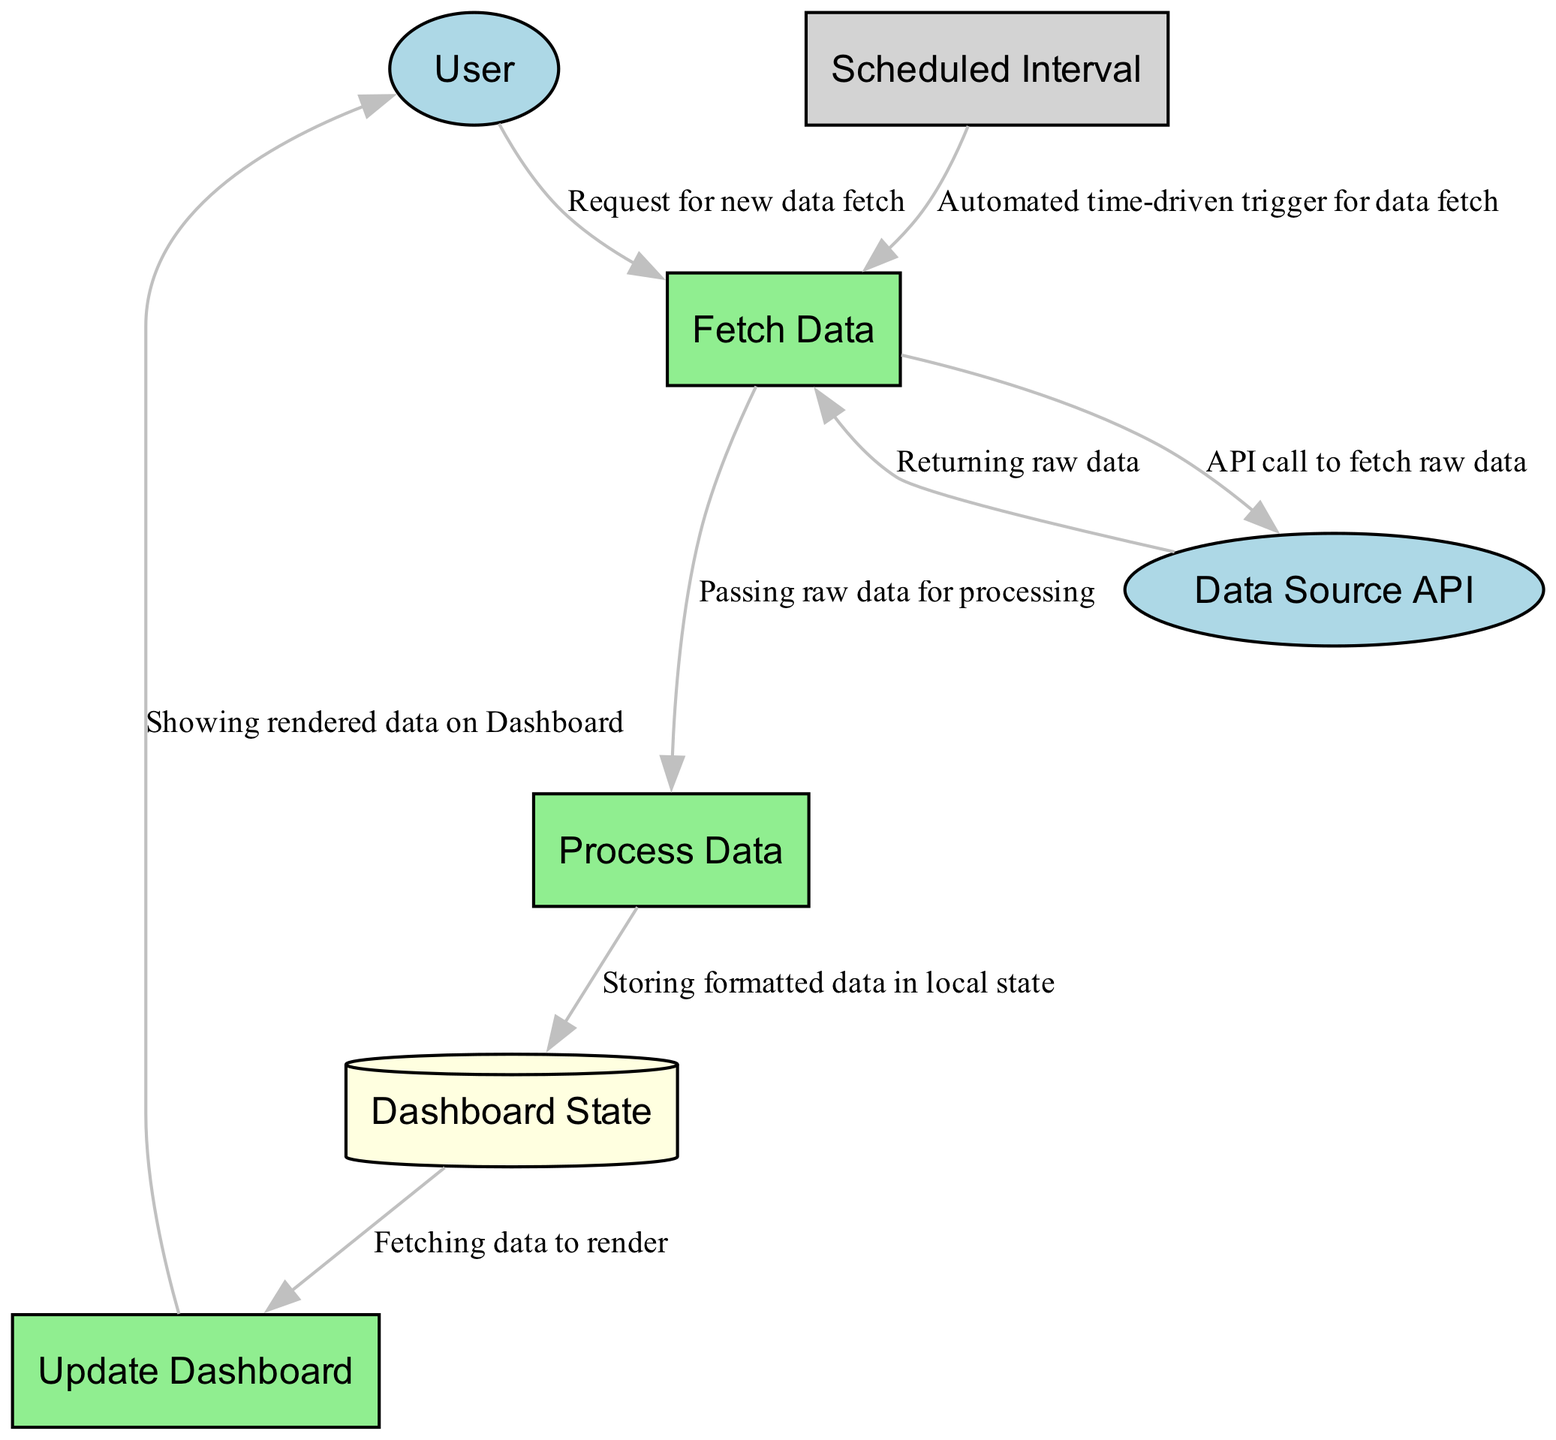What are the external entities in this diagram? The diagram shows two external entities: "User" and "Data Source API." These entities are the primary interfaces interacting with the processes in the system.
Answer: User, Data Source API How many processes are defined in the diagram? There are three distinct processes listed: "Fetch Data," "Process Data," and "Update Dashboard." This count is determined by identifying each labeled rectangle representing a process in the diagram.
Answer: 3 What data does the "Fetch Data" process output? "Fetch Data" outputs "Raw Data," as indicated in the diagram where this process has an arrow pointing to the term "Raw Data."
Answer: Raw Data Which process receives data from the "Fetch Data" process? "Process Data" receives data from "Fetch Data," as shown by the directed edge from "Fetch Data" to "Process Data," indicating the flow of raw data for further processing.
Answer: Process Data What triggers the "Fetch Data" process to execute? The "Fetch Data" process can be triggered by a "User Request" or a "Scheduled Interval," both indicated as inputs to the process. This highlights two different mechanisms for initiating the data fetch.
Answer: User Request, Scheduled Interval What is the role of the "Dashboard State" in the diagram? The "Dashboard State" serves as a data store that maintains the current state of the dashboard, receiving formatted data from the "Process Data" step and providing current state data for the "Update Dashboard" process.
Answer: Maintains current state What is the final output of the "Update Dashboard"? The final output of the "Update Dashboard" process is "Dashboard View," which indicates the rendered view of the dashboard shown to the user. The connection leading out of this process indicates this is the end result displayed.
Answer: Dashboard View Which external entity triggers data fetching through user interaction? The "User" is the external entity that initiates data fetching through requests made within the dashboard interface, shown by the arrow connecting "User" to "Fetch Data."
Answer: User How many data flows are there in this diagram? There are eight data flows identified in the diagram, each represented by arrows indicating the direction of data movement between different entities, processes, and stores.
Answer: 8 